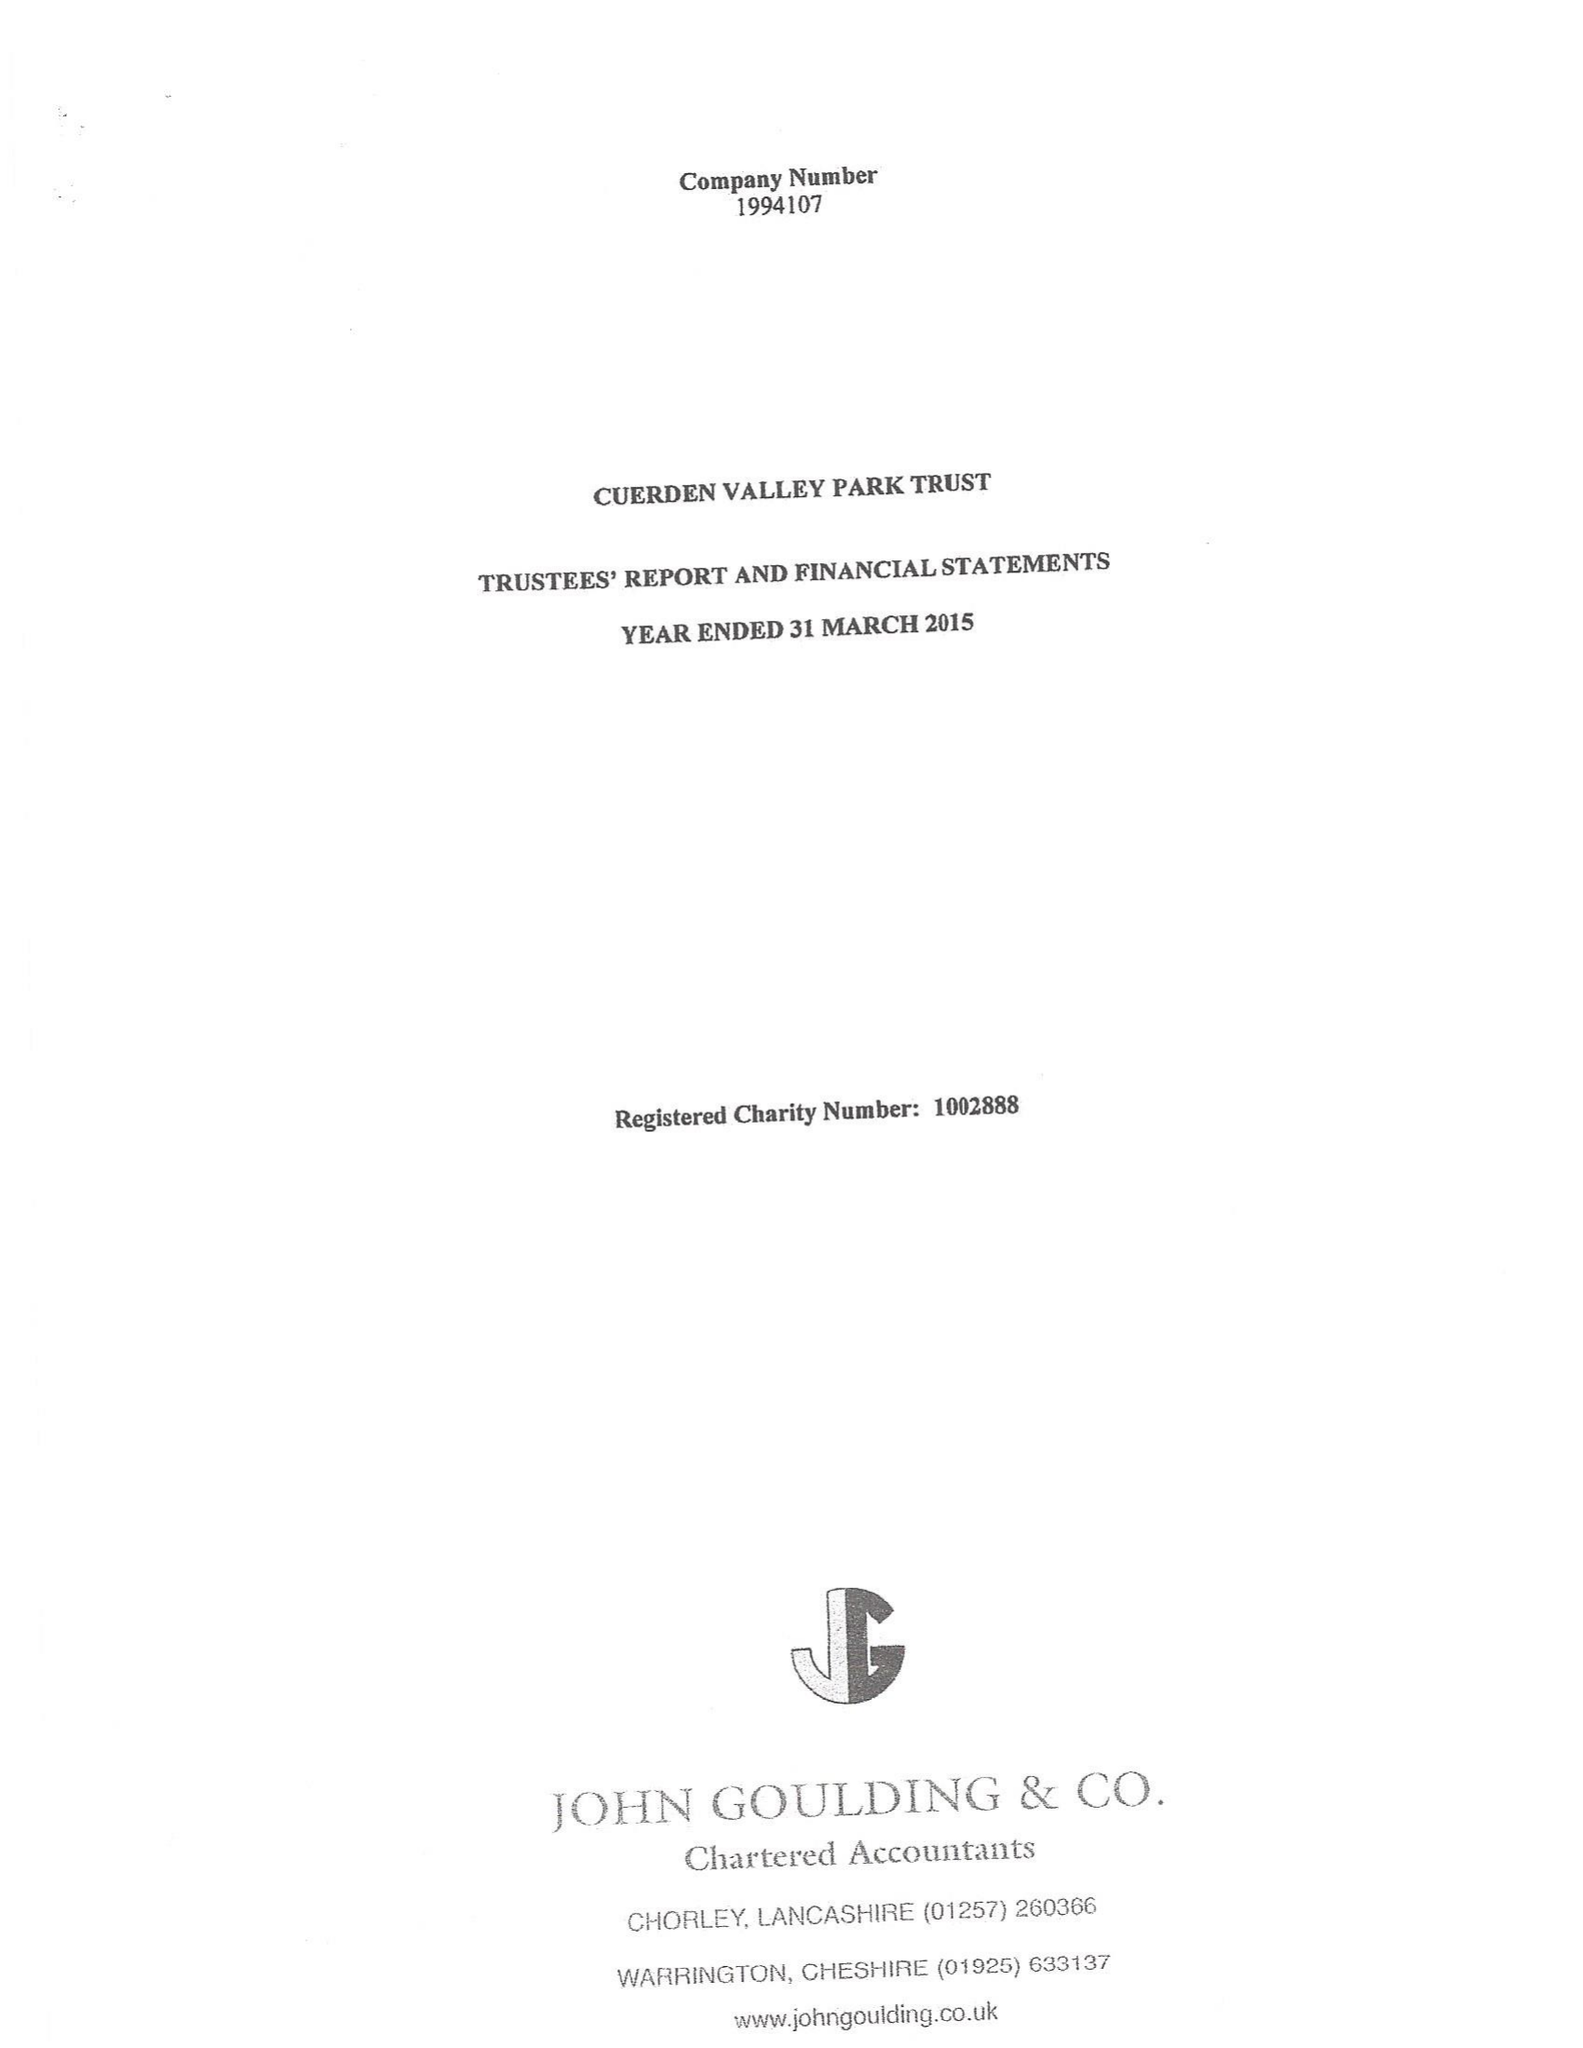What is the value for the spending_annually_in_british_pounds?
Answer the question using a single word or phrase. 286706.00 